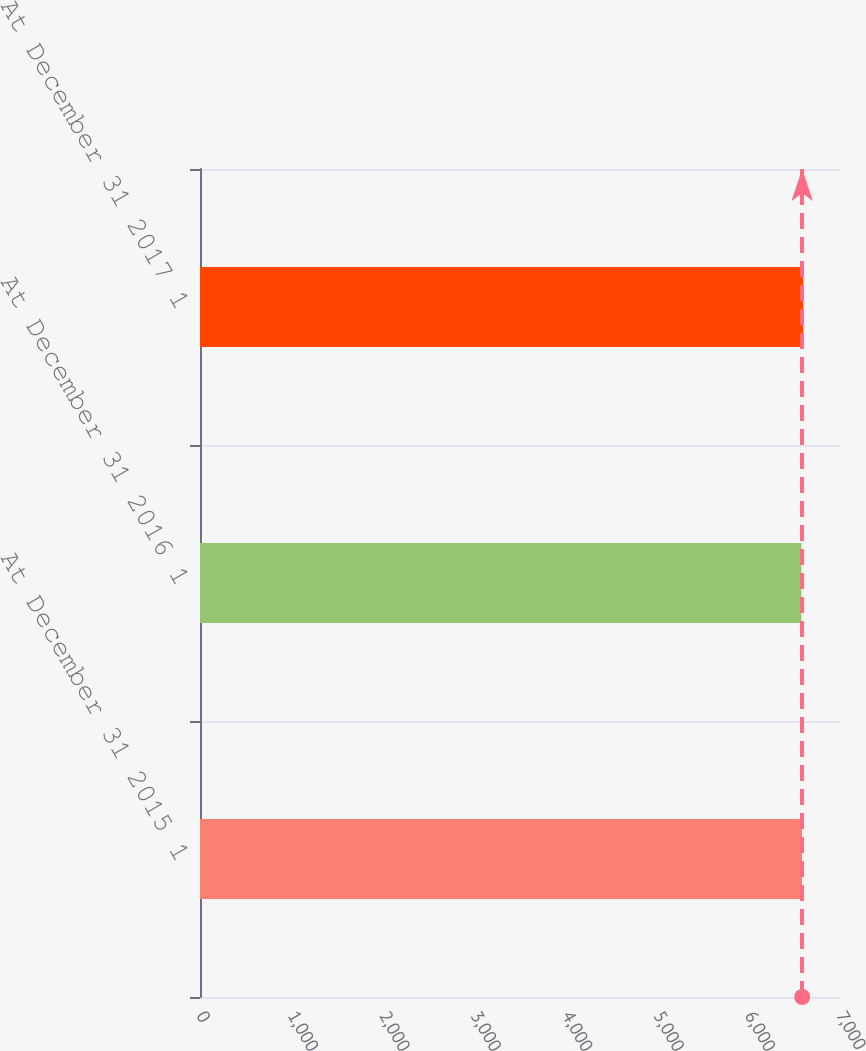Convert chart. <chart><loc_0><loc_0><loc_500><loc_500><bar_chart><fcel>At December 31 2015 1<fcel>At December 31 2016 1<fcel>At December 31 2017 1<nl><fcel>6584<fcel>6577<fcel>6597<nl></chart> 